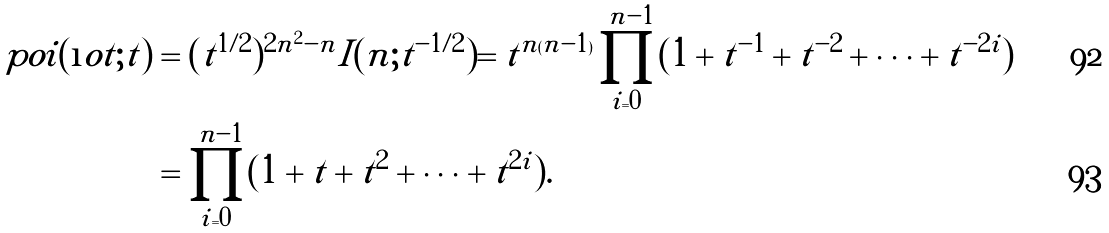<formula> <loc_0><loc_0><loc_500><loc_500>\ p o i ( \i o t ; t ) & = ( t ^ { 1 / 2 } ) ^ { 2 n ^ { 2 } - n } I ( n ; t ^ { - 1 / 2 } ) = t ^ { n ( n - 1 ) } \prod _ { i = 0 } ^ { n - 1 } ( 1 + t ^ { - 1 } + t ^ { - 2 } + \cdots + t ^ { - 2 i } ) \\ & = \prod _ { i = 0 } ^ { n - 1 } ( 1 + t + t ^ { 2 } + \cdots + t ^ { 2 i } ) .</formula> 